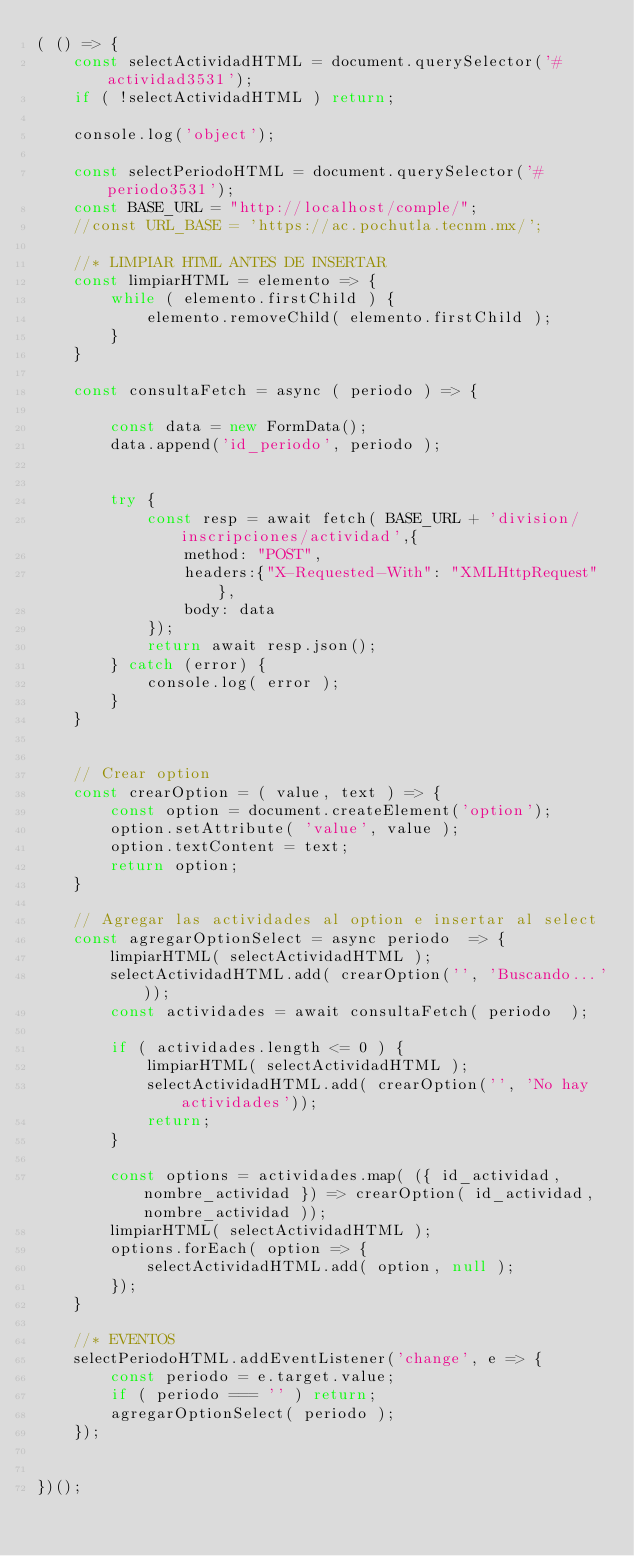Convert code to text. <code><loc_0><loc_0><loc_500><loc_500><_JavaScript_>( () => {
    const selectActividadHTML = document.querySelector('#actividad3531');
    if ( !selectActividadHTML ) return;

    console.log('object');

    const selectPeriodoHTML = document.querySelector('#periodo3531');
    const BASE_URL = "http://localhost/comple/";
    //const URL_BASE = 'https://ac.pochutla.tecnm.mx/';

    //* LIMPIAR HTML ANTES DE INSERTAR
    const limpiarHTML = elemento => {
        while ( elemento.firstChild ) {
            elemento.removeChild( elemento.firstChild );
        }
    }

    const consultaFetch = async ( periodo ) => {

        const data = new FormData();
	    data.append('id_periodo', periodo );


        try {
            const resp = await fetch( BASE_URL + 'division/inscripciones/actividad',{
                method: "POST",
                headers:{"X-Requested-With": "XMLHttpRequest"},
                body: data
            });
            return await resp.json();
        } catch (error) {
            console.log( error );
        }
    }


    // Crear option
    const crearOption = ( value, text ) => {
        const option = document.createElement('option');
        option.setAttribute( 'value', value );
        option.textContent = text;
        return option;
    }

    // Agregar las actividades al option e insertar al select
    const agregarOptionSelect = async periodo  => {
        limpiarHTML( selectActividadHTML );
        selectActividadHTML.add( crearOption('', 'Buscando...'));
        const actividades = await consultaFetch( periodo  );

        if ( actividades.length <= 0 ) {
            limpiarHTML( selectActividadHTML );
            selectActividadHTML.add( crearOption('', 'No hay actividades'));
            return;
        }

        const options = actividades.map( ({ id_actividad, nombre_actividad }) => crearOption( id_actividad, nombre_actividad ));
        limpiarHTML( selectActividadHTML );
        options.forEach( option => {
            selectActividadHTML.add( option, null );
        });
    }

    //* EVENTOS
    selectPeriodoHTML.addEventListener('change', e => {
        const periodo = e.target.value;
        if ( periodo === '' ) return;
        agregarOptionSelect( periodo );
    });


})();</code> 